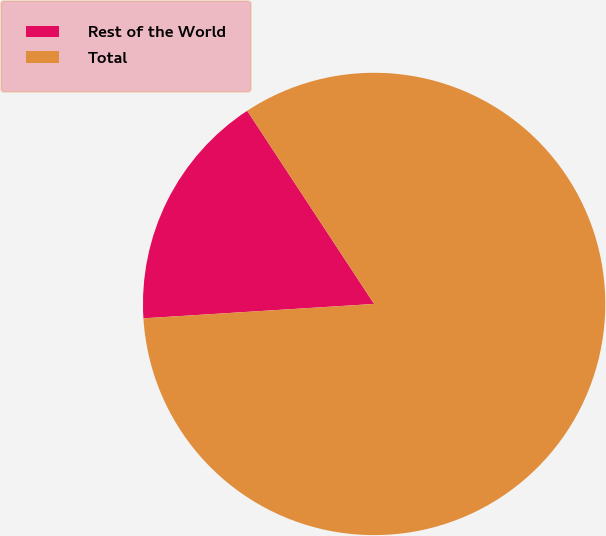Convert chart to OTSL. <chart><loc_0><loc_0><loc_500><loc_500><pie_chart><fcel>Rest of the World<fcel>Total<nl><fcel>16.74%<fcel>83.26%<nl></chart> 